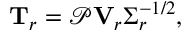<formula> <loc_0><loc_0><loc_500><loc_500>T _ { r } = \ m a t h s c r { P } V _ { r } \Sigma _ { r } ^ { - 1 / 2 } ,</formula> 